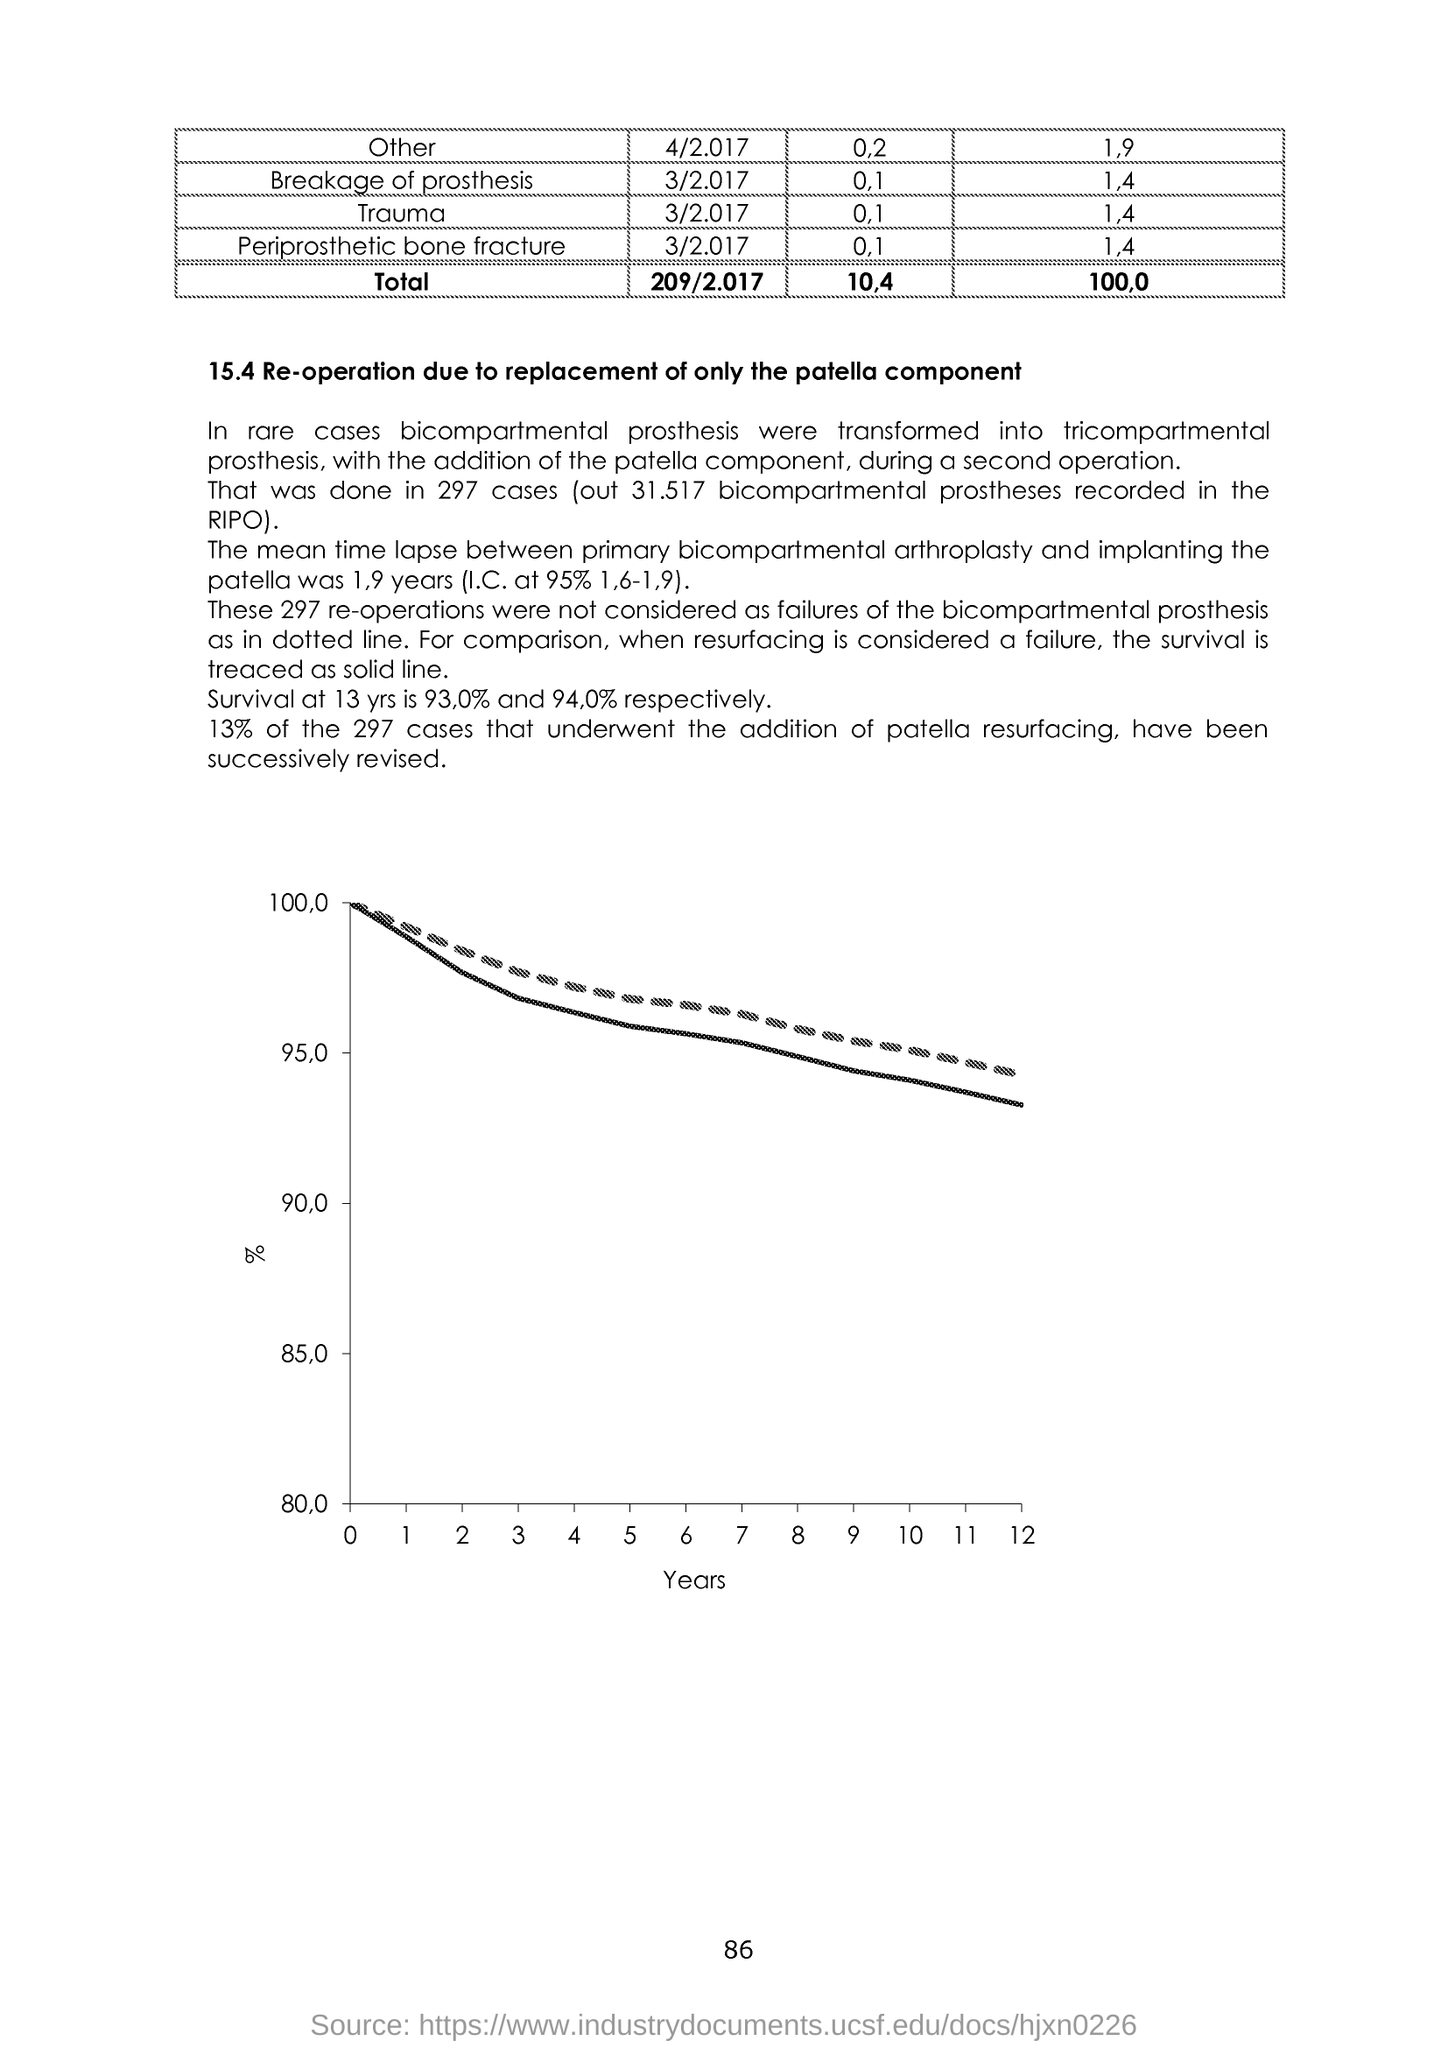What is given in the x-axis of the graph?
Ensure brevity in your answer.  Years. What is the number at bottom of the page?
Your response must be concise. 86. 